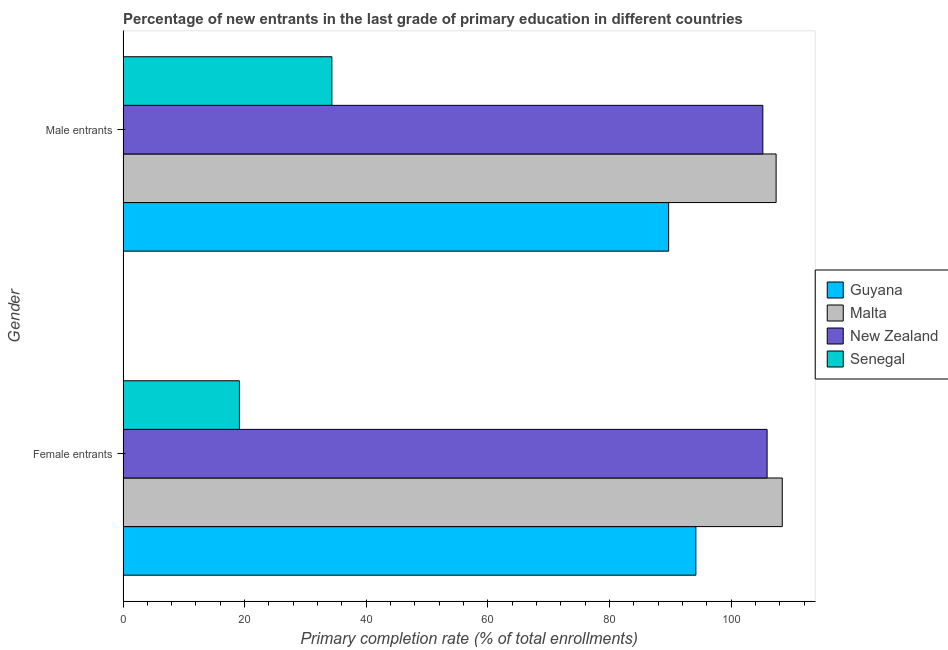How many different coloured bars are there?
Offer a terse response. 4. Are the number of bars per tick equal to the number of legend labels?
Offer a terse response. Yes. Are the number of bars on each tick of the Y-axis equal?
Your response must be concise. Yes. What is the label of the 1st group of bars from the top?
Make the answer very short. Male entrants. What is the primary completion rate of male entrants in Senegal?
Provide a short and direct response. 34.35. Across all countries, what is the maximum primary completion rate of female entrants?
Your response must be concise. 108.41. Across all countries, what is the minimum primary completion rate of male entrants?
Keep it short and to the point. 34.35. In which country was the primary completion rate of female entrants maximum?
Ensure brevity in your answer.  Malta. In which country was the primary completion rate of female entrants minimum?
Keep it short and to the point. Senegal. What is the total primary completion rate of female entrants in the graph?
Provide a short and direct response. 327.67. What is the difference between the primary completion rate of male entrants in New Zealand and that in Guyana?
Ensure brevity in your answer.  15.49. What is the difference between the primary completion rate of male entrants in Senegal and the primary completion rate of female entrants in Malta?
Your answer should be very brief. -74.06. What is the average primary completion rate of male entrants per country?
Your response must be concise. 84.17. What is the difference between the primary completion rate of male entrants and primary completion rate of female entrants in Senegal?
Keep it short and to the point. 15.21. In how many countries, is the primary completion rate of male entrants greater than 88 %?
Ensure brevity in your answer.  3. What is the ratio of the primary completion rate of male entrants in Malta to that in Guyana?
Your answer should be very brief. 1.2. Is the primary completion rate of male entrants in Senegal less than that in Guyana?
Make the answer very short. Yes. What does the 4th bar from the top in Female entrants represents?
Provide a succinct answer. Guyana. What does the 3rd bar from the bottom in Female entrants represents?
Make the answer very short. New Zealand. Are all the bars in the graph horizontal?
Ensure brevity in your answer.  Yes. How many countries are there in the graph?
Ensure brevity in your answer.  4. What is the difference between two consecutive major ticks on the X-axis?
Ensure brevity in your answer.  20. Are the values on the major ticks of X-axis written in scientific E-notation?
Offer a terse response. No. Does the graph contain grids?
Ensure brevity in your answer.  No. Where does the legend appear in the graph?
Your response must be concise. Center right. How many legend labels are there?
Provide a succinct answer. 4. What is the title of the graph?
Provide a short and direct response. Percentage of new entrants in the last grade of primary education in different countries. Does "Kyrgyz Republic" appear as one of the legend labels in the graph?
Offer a very short reply. No. What is the label or title of the X-axis?
Offer a terse response. Primary completion rate (% of total enrollments). What is the label or title of the Y-axis?
Provide a short and direct response. Gender. What is the Primary completion rate (% of total enrollments) of Guyana in Female entrants?
Offer a terse response. 94.2. What is the Primary completion rate (% of total enrollments) in Malta in Female entrants?
Provide a succinct answer. 108.41. What is the Primary completion rate (% of total enrollments) in New Zealand in Female entrants?
Your answer should be compact. 105.92. What is the Primary completion rate (% of total enrollments) of Senegal in Female entrants?
Your answer should be very brief. 19.14. What is the Primary completion rate (% of total enrollments) of Guyana in Male entrants?
Offer a very short reply. 89.73. What is the Primary completion rate (% of total enrollments) in Malta in Male entrants?
Make the answer very short. 107.4. What is the Primary completion rate (% of total enrollments) in New Zealand in Male entrants?
Offer a terse response. 105.22. What is the Primary completion rate (% of total enrollments) of Senegal in Male entrants?
Your response must be concise. 34.35. Across all Gender, what is the maximum Primary completion rate (% of total enrollments) in Guyana?
Give a very brief answer. 94.2. Across all Gender, what is the maximum Primary completion rate (% of total enrollments) of Malta?
Make the answer very short. 108.41. Across all Gender, what is the maximum Primary completion rate (% of total enrollments) in New Zealand?
Your response must be concise. 105.92. Across all Gender, what is the maximum Primary completion rate (% of total enrollments) in Senegal?
Your answer should be very brief. 34.35. Across all Gender, what is the minimum Primary completion rate (% of total enrollments) of Guyana?
Provide a short and direct response. 89.73. Across all Gender, what is the minimum Primary completion rate (% of total enrollments) in Malta?
Ensure brevity in your answer.  107.4. Across all Gender, what is the minimum Primary completion rate (% of total enrollments) of New Zealand?
Ensure brevity in your answer.  105.22. Across all Gender, what is the minimum Primary completion rate (% of total enrollments) in Senegal?
Provide a succinct answer. 19.14. What is the total Primary completion rate (% of total enrollments) in Guyana in the graph?
Your answer should be very brief. 183.93. What is the total Primary completion rate (% of total enrollments) of Malta in the graph?
Offer a very short reply. 215.81. What is the total Primary completion rate (% of total enrollments) of New Zealand in the graph?
Provide a succinct answer. 211.13. What is the total Primary completion rate (% of total enrollments) in Senegal in the graph?
Keep it short and to the point. 53.49. What is the difference between the Primary completion rate (% of total enrollments) in Guyana in Female entrants and that in Male entrants?
Provide a short and direct response. 4.48. What is the difference between the Primary completion rate (% of total enrollments) of Malta in Female entrants and that in Male entrants?
Make the answer very short. 1.01. What is the difference between the Primary completion rate (% of total enrollments) of New Zealand in Female entrants and that in Male entrants?
Your answer should be compact. 0.7. What is the difference between the Primary completion rate (% of total enrollments) of Senegal in Female entrants and that in Male entrants?
Provide a short and direct response. -15.21. What is the difference between the Primary completion rate (% of total enrollments) of Guyana in Female entrants and the Primary completion rate (% of total enrollments) of Malta in Male entrants?
Provide a short and direct response. -13.2. What is the difference between the Primary completion rate (% of total enrollments) of Guyana in Female entrants and the Primary completion rate (% of total enrollments) of New Zealand in Male entrants?
Your answer should be compact. -11.01. What is the difference between the Primary completion rate (% of total enrollments) of Guyana in Female entrants and the Primary completion rate (% of total enrollments) of Senegal in Male entrants?
Give a very brief answer. 59.86. What is the difference between the Primary completion rate (% of total enrollments) in Malta in Female entrants and the Primary completion rate (% of total enrollments) in New Zealand in Male entrants?
Make the answer very short. 3.19. What is the difference between the Primary completion rate (% of total enrollments) of Malta in Female entrants and the Primary completion rate (% of total enrollments) of Senegal in Male entrants?
Offer a very short reply. 74.06. What is the difference between the Primary completion rate (% of total enrollments) of New Zealand in Female entrants and the Primary completion rate (% of total enrollments) of Senegal in Male entrants?
Your answer should be very brief. 71.57. What is the average Primary completion rate (% of total enrollments) in Guyana per Gender?
Keep it short and to the point. 91.96. What is the average Primary completion rate (% of total enrollments) of Malta per Gender?
Give a very brief answer. 107.91. What is the average Primary completion rate (% of total enrollments) of New Zealand per Gender?
Your answer should be very brief. 105.57. What is the average Primary completion rate (% of total enrollments) in Senegal per Gender?
Your answer should be compact. 26.74. What is the difference between the Primary completion rate (% of total enrollments) in Guyana and Primary completion rate (% of total enrollments) in Malta in Female entrants?
Provide a succinct answer. -14.21. What is the difference between the Primary completion rate (% of total enrollments) in Guyana and Primary completion rate (% of total enrollments) in New Zealand in Female entrants?
Your response must be concise. -11.71. What is the difference between the Primary completion rate (% of total enrollments) in Guyana and Primary completion rate (% of total enrollments) in Senegal in Female entrants?
Offer a terse response. 75.06. What is the difference between the Primary completion rate (% of total enrollments) in Malta and Primary completion rate (% of total enrollments) in New Zealand in Female entrants?
Offer a terse response. 2.49. What is the difference between the Primary completion rate (% of total enrollments) of Malta and Primary completion rate (% of total enrollments) of Senegal in Female entrants?
Your answer should be compact. 89.27. What is the difference between the Primary completion rate (% of total enrollments) of New Zealand and Primary completion rate (% of total enrollments) of Senegal in Female entrants?
Your response must be concise. 86.77. What is the difference between the Primary completion rate (% of total enrollments) of Guyana and Primary completion rate (% of total enrollments) of Malta in Male entrants?
Make the answer very short. -17.67. What is the difference between the Primary completion rate (% of total enrollments) in Guyana and Primary completion rate (% of total enrollments) in New Zealand in Male entrants?
Provide a succinct answer. -15.49. What is the difference between the Primary completion rate (% of total enrollments) in Guyana and Primary completion rate (% of total enrollments) in Senegal in Male entrants?
Keep it short and to the point. 55.38. What is the difference between the Primary completion rate (% of total enrollments) of Malta and Primary completion rate (% of total enrollments) of New Zealand in Male entrants?
Offer a terse response. 2.18. What is the difference between the Primary completion rate (% of total enrollments) of Malta and Primary completion rate (% of total enrollments) of Senegal in Male entrants?
Your response must be concise. 73.05. What is the difference between the Primary completion rate (% of total enrollments) in New Zealand and Primary completion rate (% of total enrollments) in Senegal in Male entrants?
Offer a terse response. 70.87. What is the ratio of the Primary completion rate (% of total enrollments) in Guyana in Female entrants to that in Male entrants?
Your answer should be compact. 1.05. What is the ratio of the Primary completion rate (% of total enrollments) in Malta in Female entrants to that in Male entrants?
Offer a very short reply. 1.01. What is the ratio of the Primary completion rate (% of total enrollments) of New Zealand in Female entrants to that in Male entrants?
Your answer should be compact. 1.01. What is the ratio of the Primary completion rate (% of total enrollments) in Senegal in Female entrants to that in Male entrants?
Provide a succinct answer. 0.56. What is the difference between the highest and the second highest Primary completion rate (% of total enrollments) of Guyana?
Provide a succinct answer. 4.48. What is the difference between the highest and the second highest Primary completion rate (% of total enrollments) of Malta?
Provide a succinct answer. 1.01. What is the difference between the highest and the second highest Primary completion rate (% of total enrollments) in New Zealand?
Offer a very short reply. 0.7. What is the difference between the highest and the second highest Primary completion rate (% of total enrollments) of Senegal?
Make the answer very short. 15.21. What is the difference between the highest and the lowest Primary completion rate (% of total enrollments) of Guyana?
Give a very brief answer. 4.48. What is the difference between the highest and the lowest Primary completion rate (% of total enrollments) of Malta?
Make the answer very short. 1.01. What is the difference between the highest and the lowest Primary completion rate (% of total enrollments) in New Zealand?
Provide a short and direct response. 0.7. What is the difference between the highest and the lowest Primary completion rate (% of total enrollments) in Senegal?
Provide a short and direct response. 15.21. 